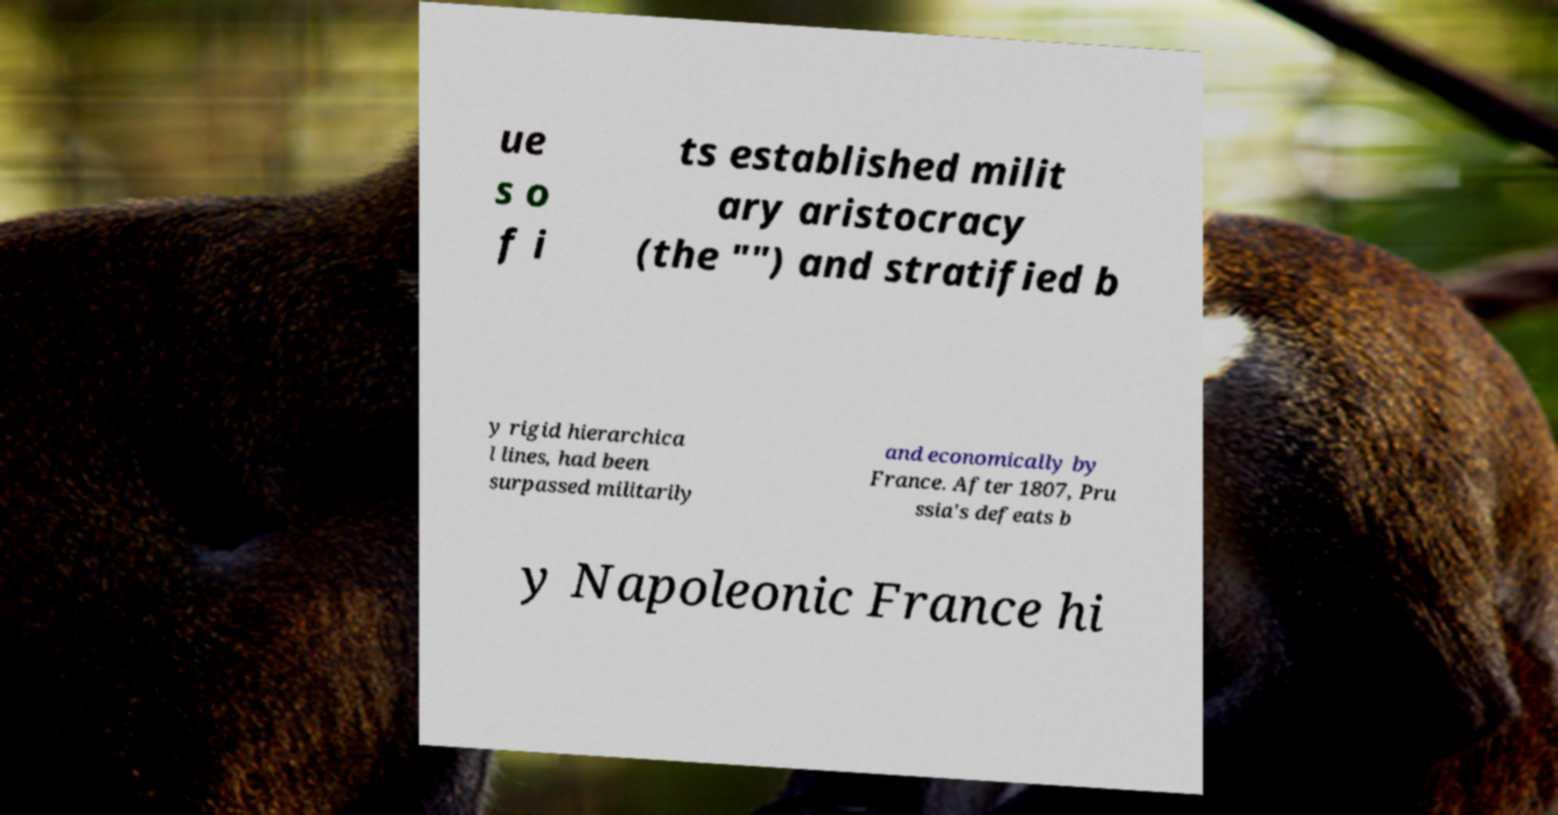What messages or text are displayed in this image? I need them in a readable, typed format. ue s o f i ts established milit ary aristocracy (the "") and stratified b y rigid hierarchica l lines, had been surpassed militarily and economically by France. After 1807, Pru ssia's defeats b y Napoleonic France hi 